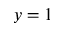Convert formula to latex. <formula><loc_0><loc_0><loc_500><loc_500>y = 1</formula> 